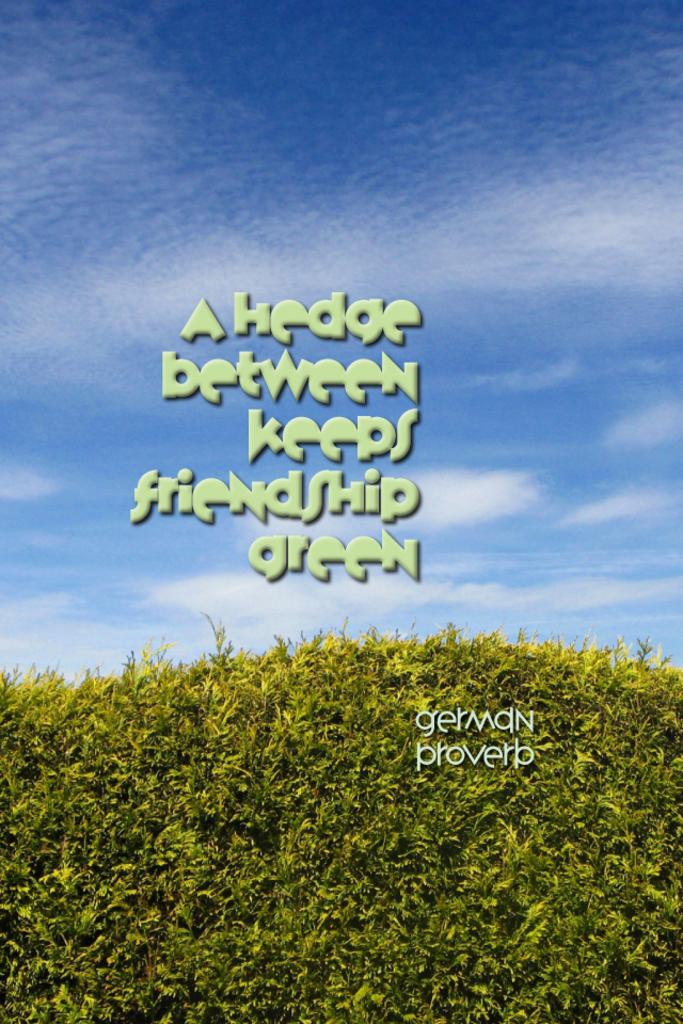What is present in the image besides visual elements? The image contains text. What type of plants can be seen at the bottom of the image? There are small plants at the bottom of the image. What can be seen in the sky in the background of the image? There are clouds in the sky in the background of the image. Can you tell me how many cows are grazing in the image? There are no cows present in the image. What type of clothing is the girl wearing in the image? There is no girl present in the image. 